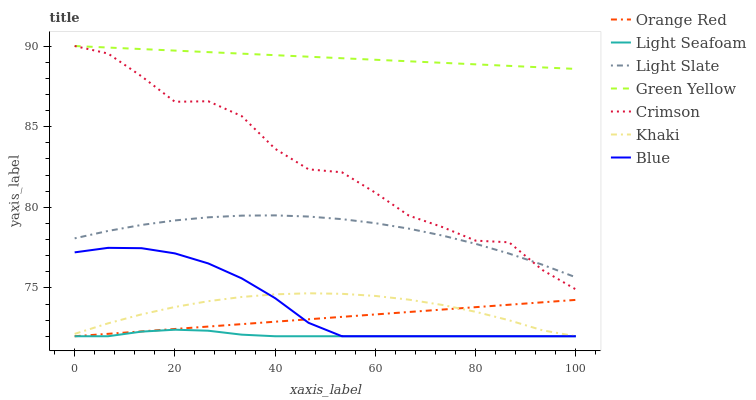Does Light Seafoam have the minimum area under the curve?
Answer yes or no. Yes. Does Green Yellow have the maximum area under the curve?
Answer yes or no. Yes. Does Light Slate have the minimum area under the curve?
Answer yes or no. No. Does Light Slate have the maximum area under the curve?
Answer yes or no. No. Is Green Yellow the smoothest?
Answer yes or no. Yes. Is Crimson the roughest?
Answer yes or no. Yes. Is Light Seafoam the smoothest?
Answer yes or no. No. Is Light Seafoam the roughest?
Answer yes or no. No. Does Blue have the lowest value?
Answer yes or no. Yes. Does Light Slate have the lowest value?
Answer yes or no. No. Does Green Yellow have the highest value?
Answer yes or no. Yes. Does Light Slate have the highest value?
Answer yes or no. No. Is Light Slate less than Green Yellow?
Answer yes or no. Yes. Is Green Yellow greater than Khaki?
Answer yes or no. Yes. Does Khaki intersect Blue?
Answer yes or no. Yes. Is Khaki less than Blue?
Answer yes or no. No. Is Khaki greater than Blue?
Answer yes or no. No. Does Light Slate intersect Green Yellow?
Answer yes or no. No. 